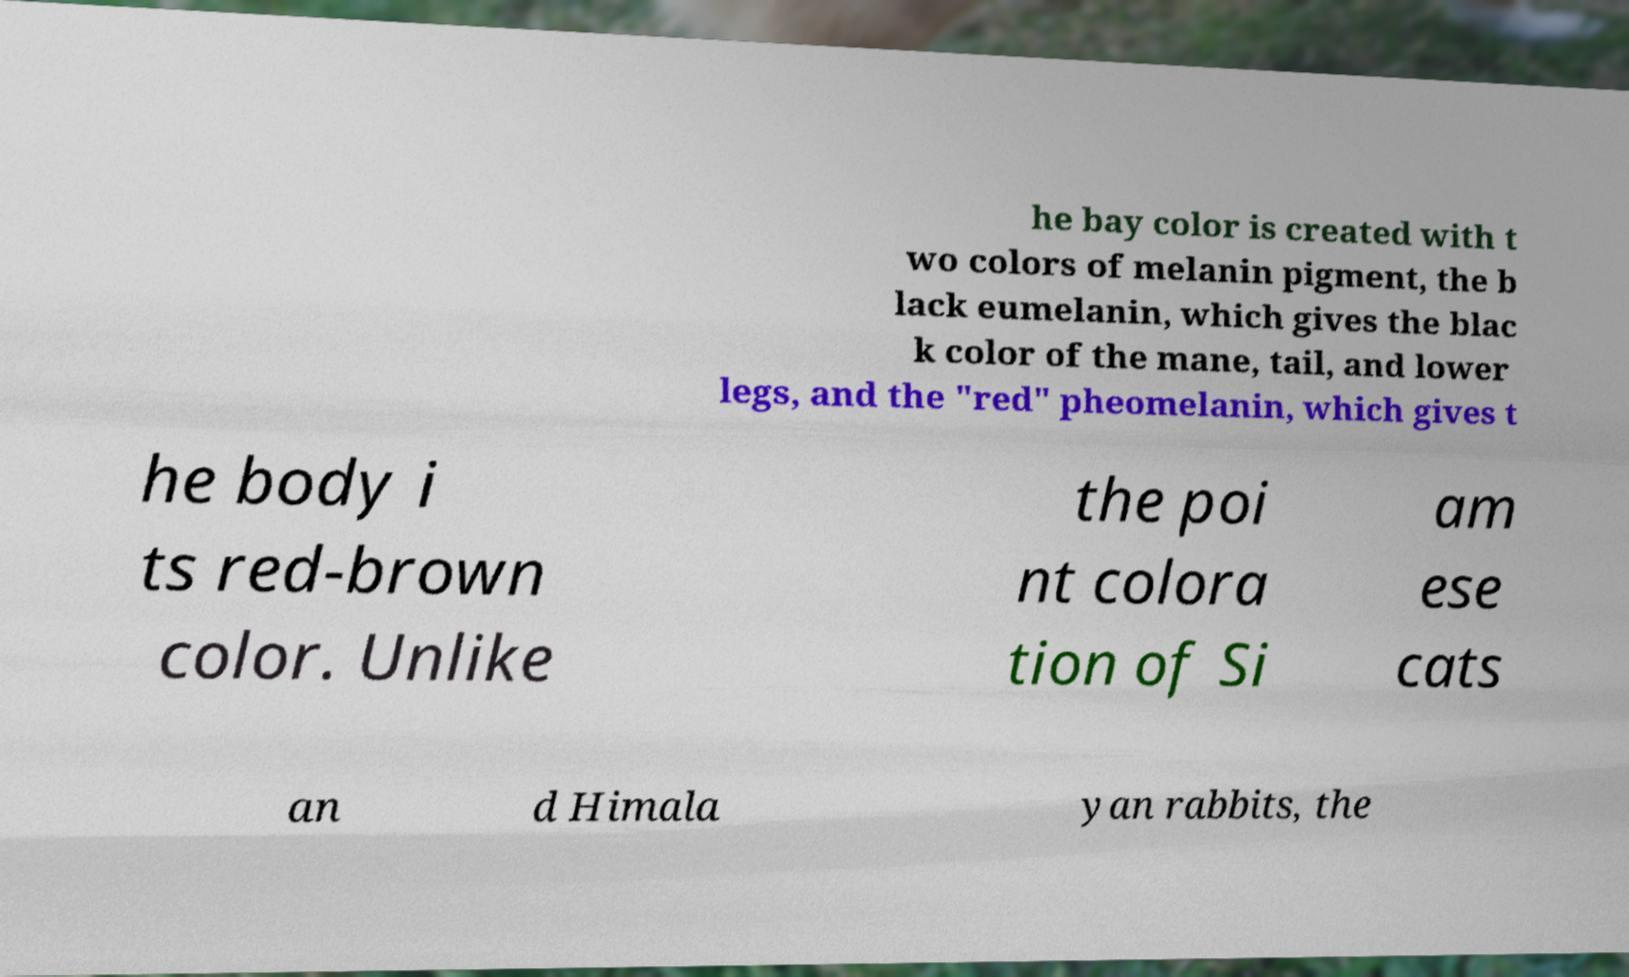Can you read and provide the text displayed in the image?This photo seems to have some interesting text. Can you extract and type it out for me? he bay color is created with t wo colors of melanin pigment, the b lack eumelanin, which gives the blac k color of the mane, tail, and lower legs, and the "red" pheomelanin, which gives t he body i ts red-brown color. Unlike the poi nt colora tion of Si am ese cats an d Himala yan rabbits, the 